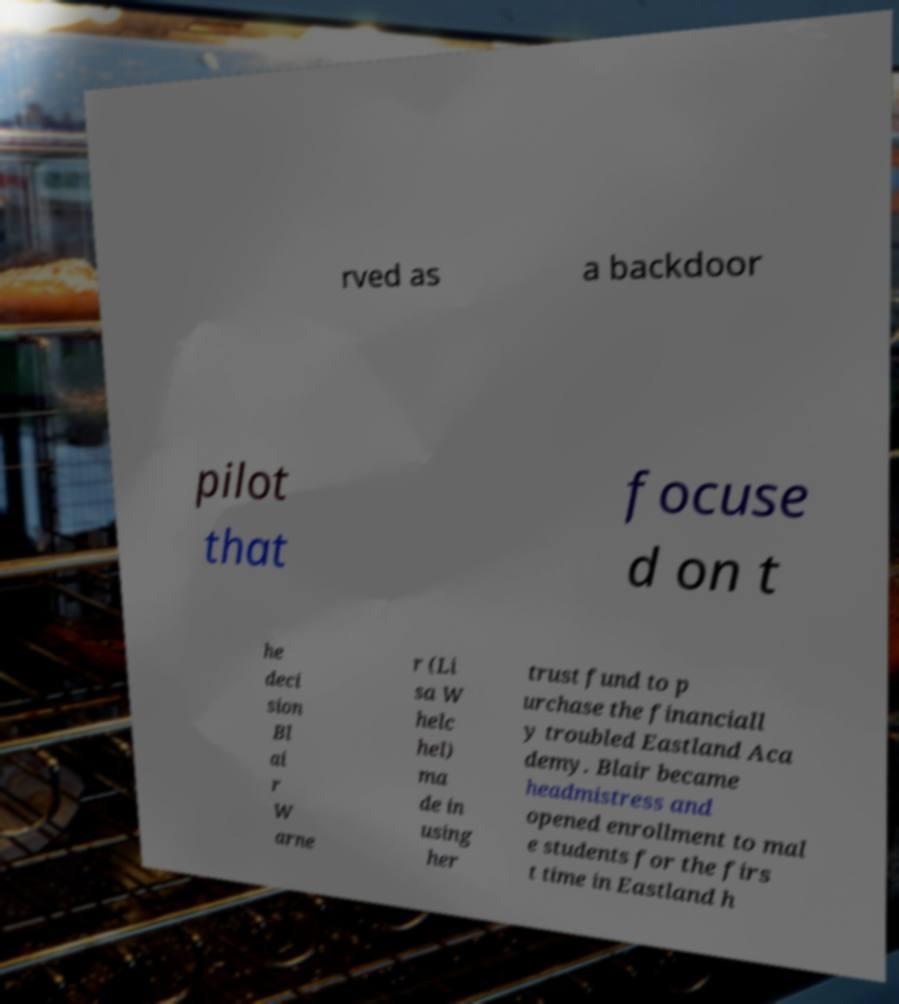There's text embedded in this image that I need extracted. Can you transcribe it verbatim? rved as a backdoor pilot that focuse d on t he deci sion Bl ai r W arne r (Li sa W helc hel) ma de in using her trust fund to p urchase the financiall y troubled Eastland Aca demy. Blair became headmistress and opened enrollment to mal e students for the firs t time in Eastland h 